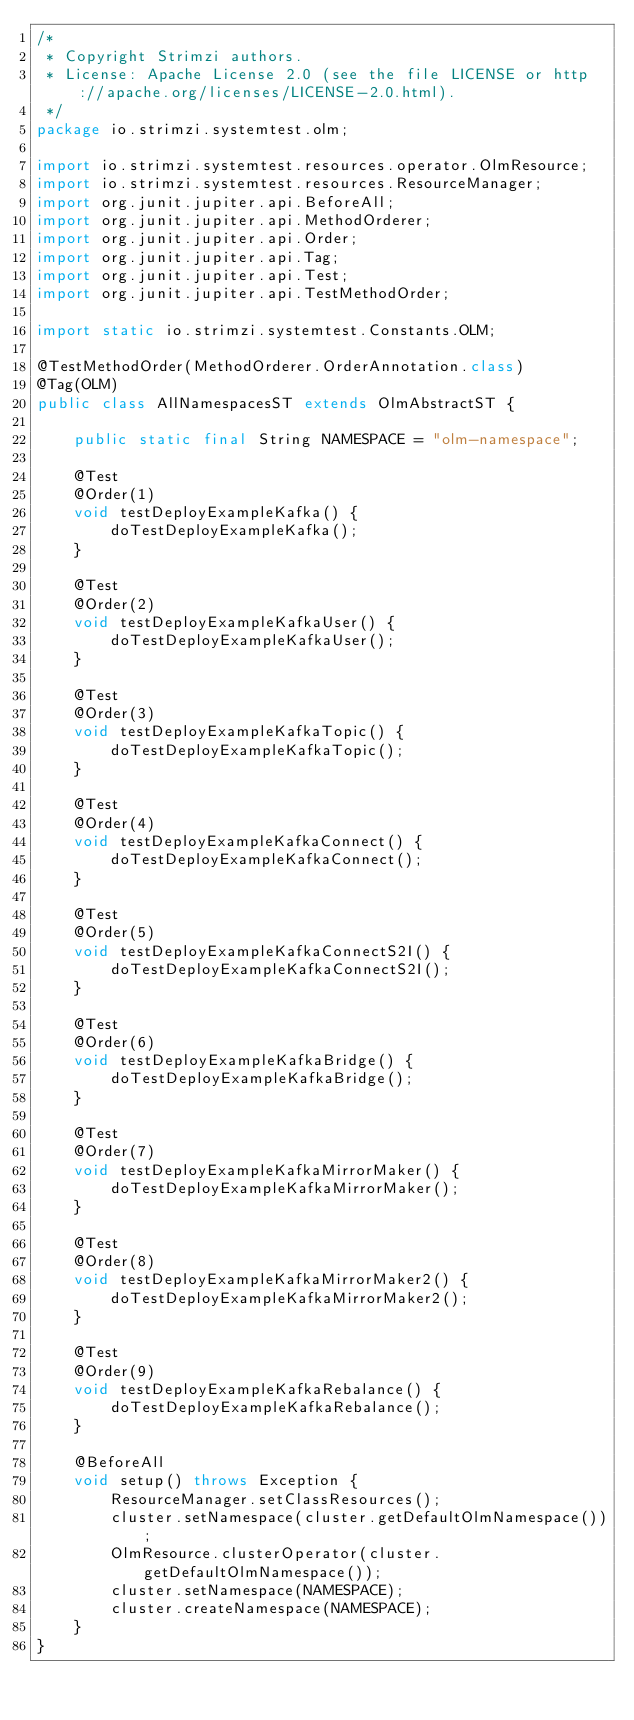<code> <loc_0><loc_0><loc_500><loc_500><_Java_>/*
 * Copyright Strimzi authors.
 * License: Apache License 2.0 (see the file LICENSE or http://apache.org/licenses/LICENSE-2.0.html).
 */
package io.strimzi.systemtest.olm;

import io.strimzi.systemtest.resources.operator.OlmResource;
import io.strimzi.systemtest.resources.ResourceManager;
import org.junit.jupiter.api.BeforeAll;
import org.junit.jupiter.api.MethodOrderer;
import org.junit.jupiter.api.Order;
import org.junit.jupiter.api.Tag;
import org.junit.jupiter.api.Test;
import org.junit.jupiter.api.TestMethodOrder;

import static io.strimzi.systemtest.Constants.OLM;

@TestMethodOrder(MethodOrderer.OrderAnnotation.class)
@Tag(OLM)
public class AllNamespacesST extends OlmAbstractST {

    public static final String NAMESPACE = "olm-namespace";

    @Test
    @Order(1)
    void testDeployExampleKafka() {
        doTestDeployExampleKafka();
    }

    @Test
    @Order(2)
    void testDeployExampleKafkaUser() {
        doTestDeployExampleKafkaUser();
    }

    @Test
    @Order(3)
    void testDeployExampleKafkaTopic() {
        doTestDeployExampleKafkaTopic();
    }

    @Test
    @Order(4)
    void testDeployExampleKafkaConnect() {
        doTestDeployExampleKafkaConnect();
    }

    @Test
    @Order(5)
    void testDeployExampleKafkaConnectS2I() {
        doTestDeployExampleKafkaConnectS2I();
    }

    @Test
    @Order(6)
    void testDeployExampleKafkaBridge() {
        doTestDeployExampleKafkaBridge();
    }

    @Test
    @Order(7)
    void testDeployExampleKafkaMirrorMaker() {
        doTestDeployExampleKafkaMirrorMaker();
    }

    @Test
    @Order(8)
    void testDeployExampleKafkaMirrorMaker2() {
        doTestDeployExampleKafkaMirrorMaker2();
    }

    @Test
    @Order(9)
    void testDeployExampleKafkaRebalance() {
        doTestDeployExampleKafkaRebalance();
    }

    @BeforeAll
    void setup() throws Exception {
        ResourceManager.setClassResources();
        cluster.setNamespace(cluster.getDefaultOlmNamespace());
        OlmResource.clusterOperator(cluster.getDefaultOlmNamespace());
        cluster.setNamespace(NAMESPACE);
        cluster.createNamespace(NAMESPACE);
    }
}
</code> 